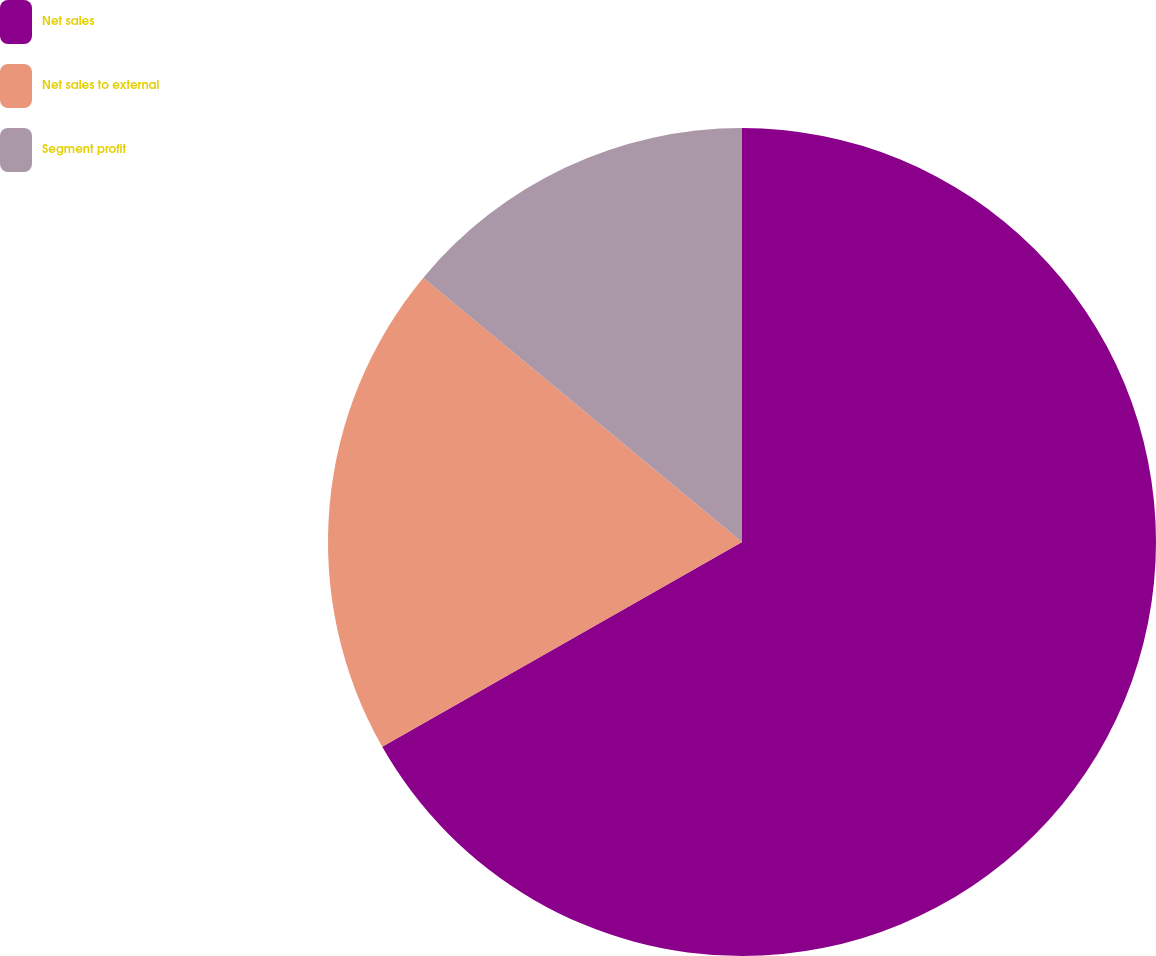Convert chart. <chart><loc_0><loc_0><loc_500><loc_500><pie_chart><fcel>Net sales<fcel>Net sales to external<fcel>Segment profit<nl><fcel>66.77%<fcel>19.26%<fcel>13.98%<nl></chart> 